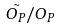Convert formula to latex. <formula><loc_0><loc_0><loc_500><loc_500>\tilde { O _ { P } } / O _ { P }</formula> 